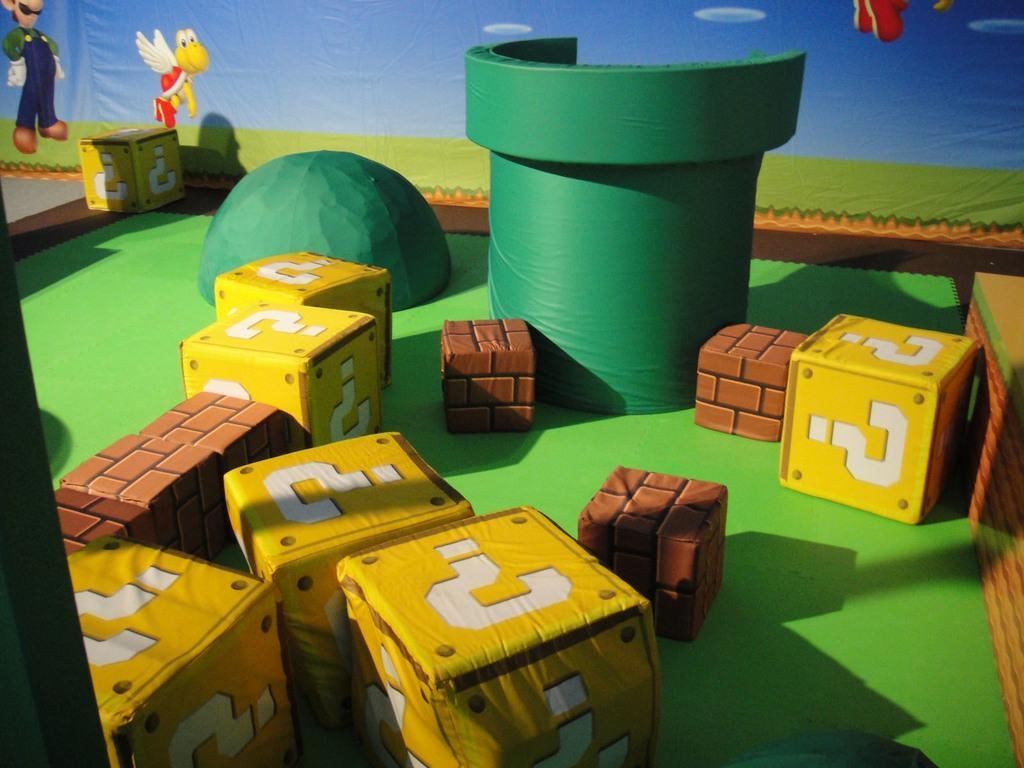Describe this image in one or two sentences. In this image I can see cubes. Few cubes representing brick blocks and on few cubes there are question marks. Also there are some objects and in the background it looks like a banner. 